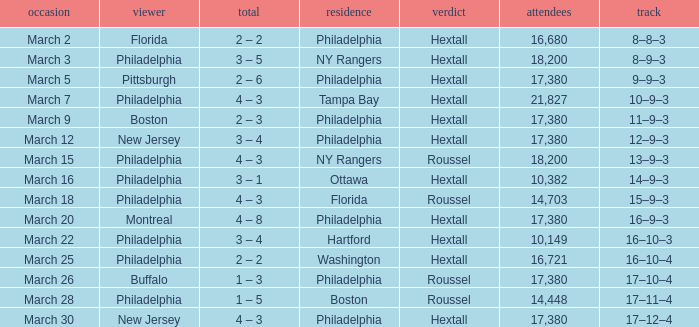Date of march 30 involves what home? Philadelphia. 